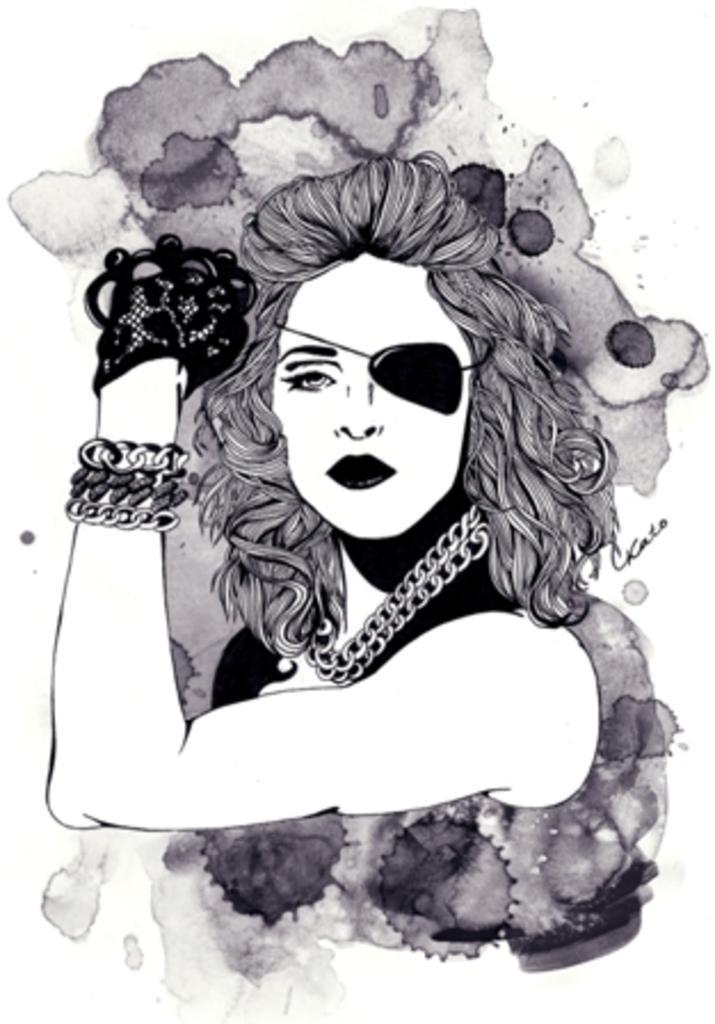Can you describe this image briefly? In this picture I can see a drawing of a woman with an eye-patch. 